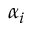Convert formula to latex. <formula><loc_0><loc_0><loc_500><loc_500>\alpha _ { i }</formula> 